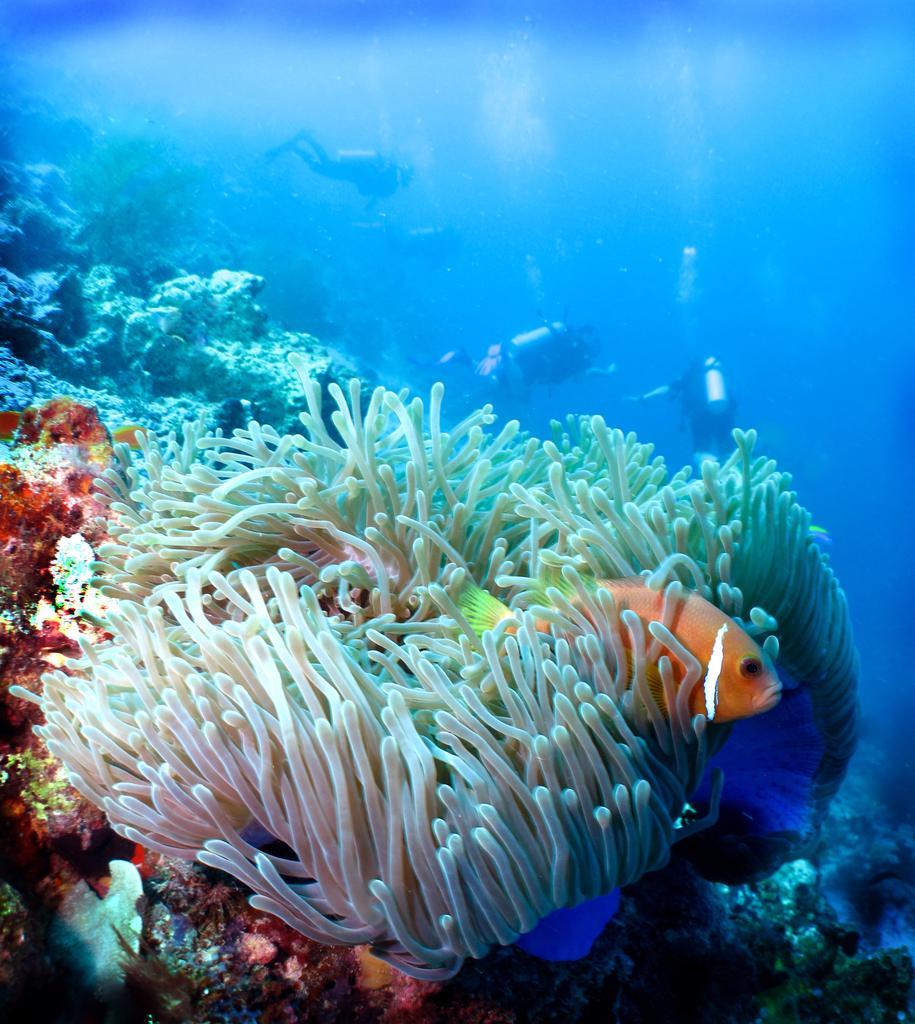How would you summarize this image in a sentence or two? In this image I can see the picture of the underwater. I can see a fish which is gold and white in color, few other aquatic animals, few persons and the blue colored water. 